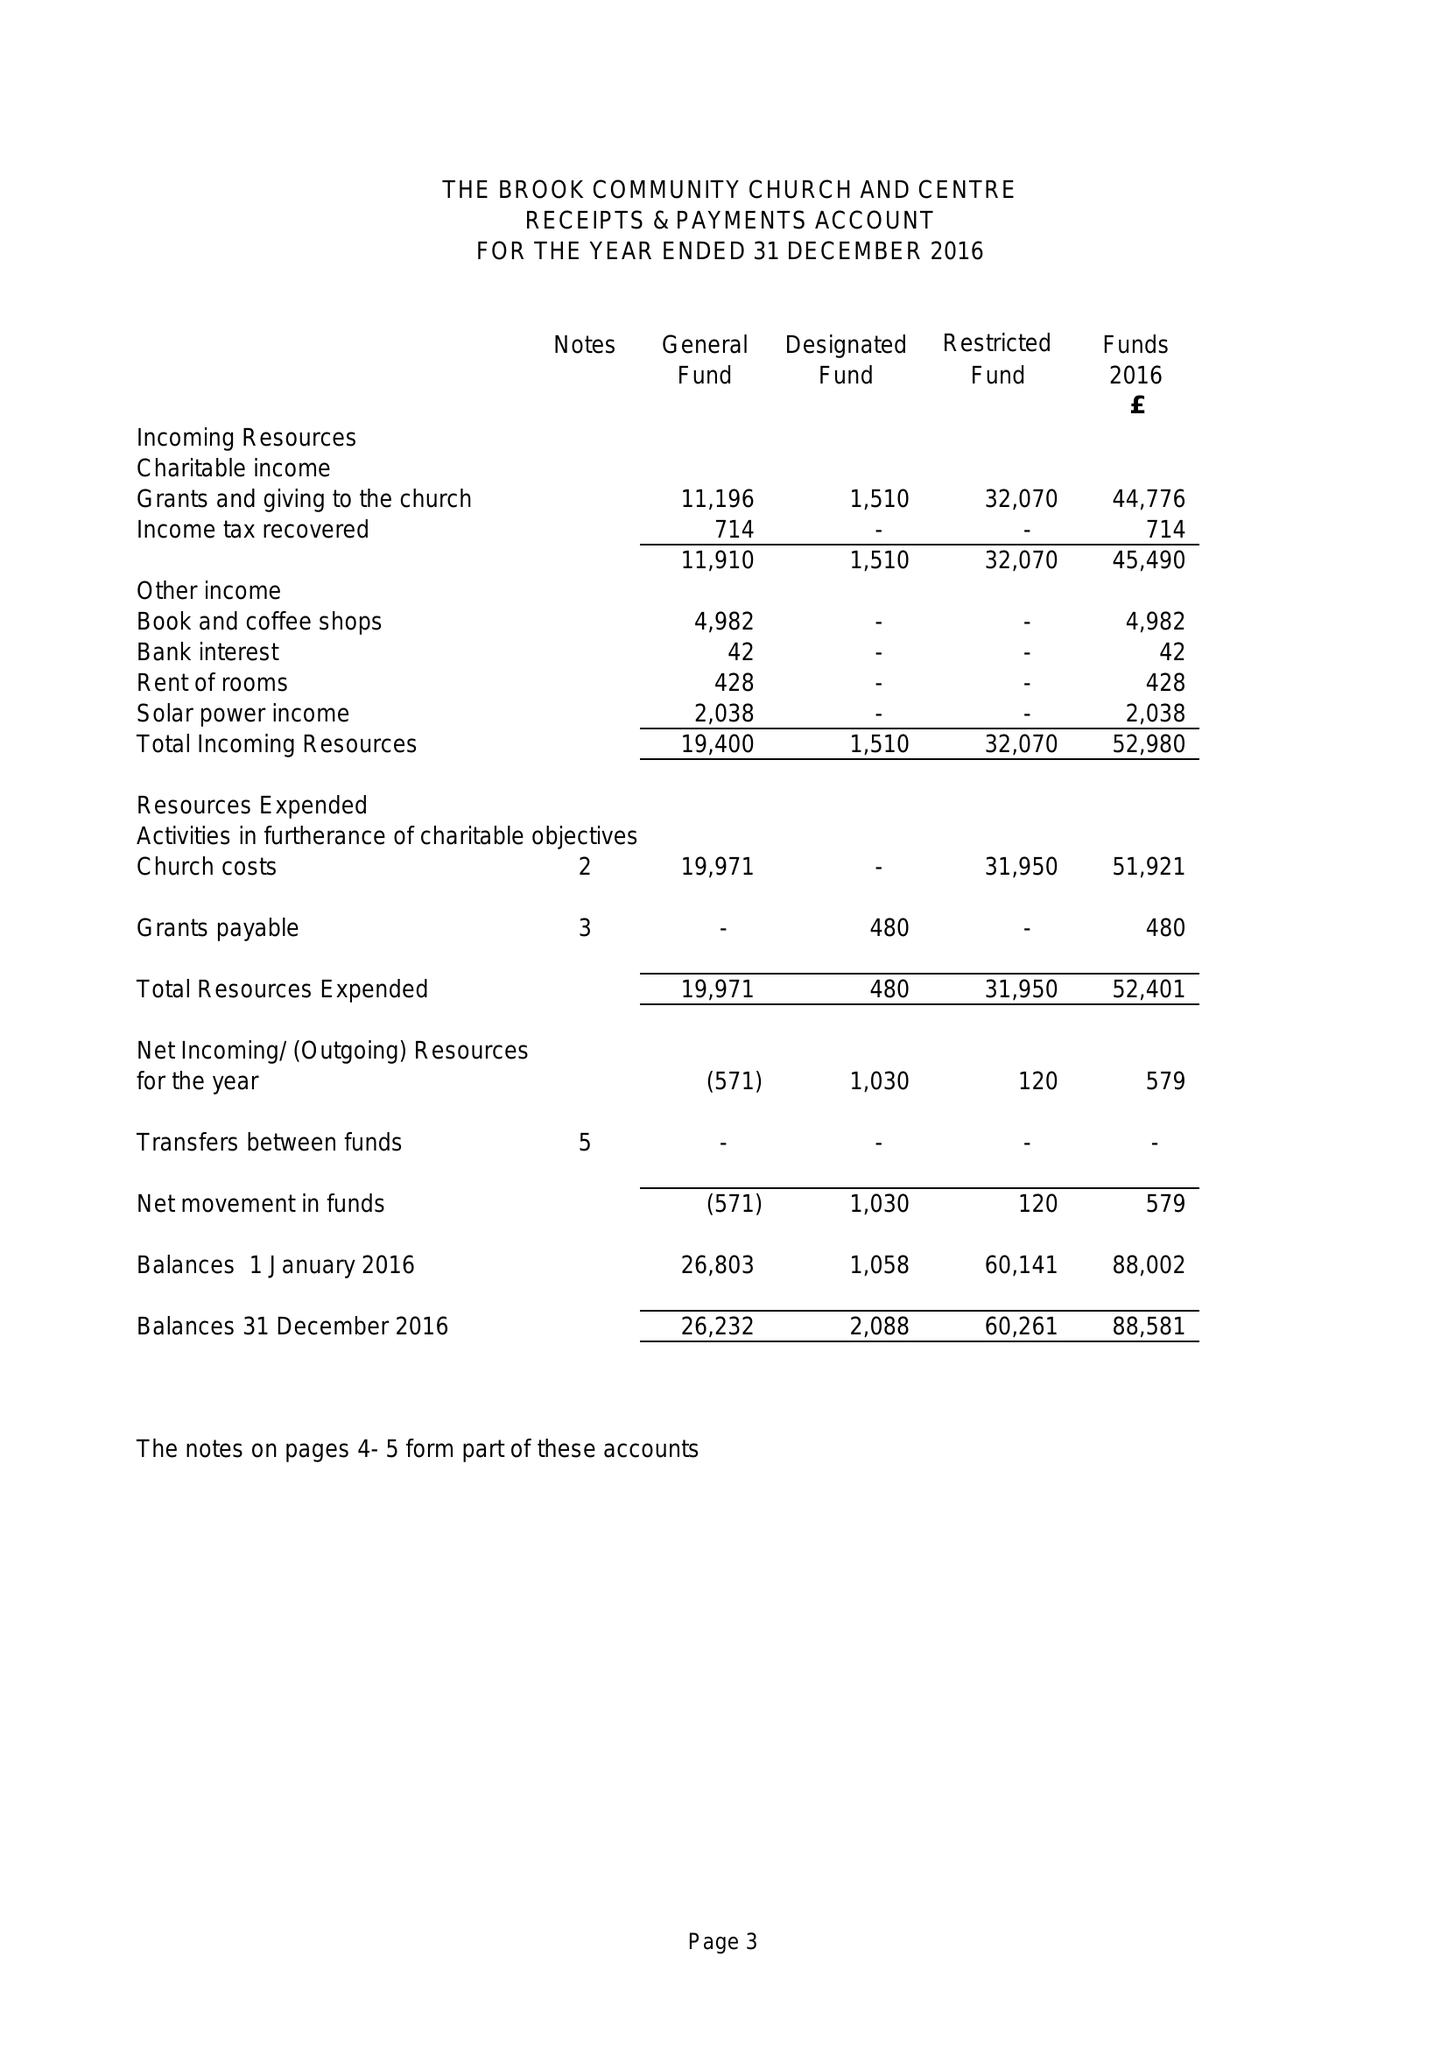What is the value for the charity_number?
Answer the question using a single word or phrase. 1052624 